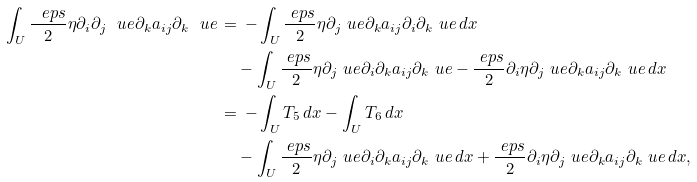<formula> <loc_0><loc_0><loc_500><loc_500>\int _ { U } \frac { \ e p s } { 2 } \eta \partial _ { i } \partial _ { j } \ u e \partial _ { k } a _ { i j } \partial _ { k } \ u e \, & = \, - \int _ { U } \frac { \ e p s } { 2 } \eta \partial _ { j } \ u e \partial _ { k } { a } _ { i j } \partial _ { i } \partial _ { k } \ u e \, d x \\ & \quad - \int _ { U } \frac { \ e p s } { 2 } \eta \partial _ { j } \ u e \partial _ { i } \partial _ { k } a _ { i j } \partial _ { k } \ u e - \frac { \ e p s } { 2 } \partial _ { i } \eta \partial _ { j } \ u e \partial _ { k } a _ { i j } \partial _ { k } \ u e \, d x \\ & = \, - \int _ { U } T _ { 5 } \, d x - \int _ { U } T _ { 6 } \, d x \\ & \quad - \int _ { U } \frac { \ e p s } { 2 } \eta \partial _ { j } \ u e \partial _ { i } \partial _ { k } a _ { i j } \partial _ { k } \ u e \, d x + \frac { \ e p s } { 2 } \partial _ { i } \eta \partial _ { j } \ u e \partial _ { k } a _ { i j } \partial _ { k } \ u e \, d x ,</formula> 